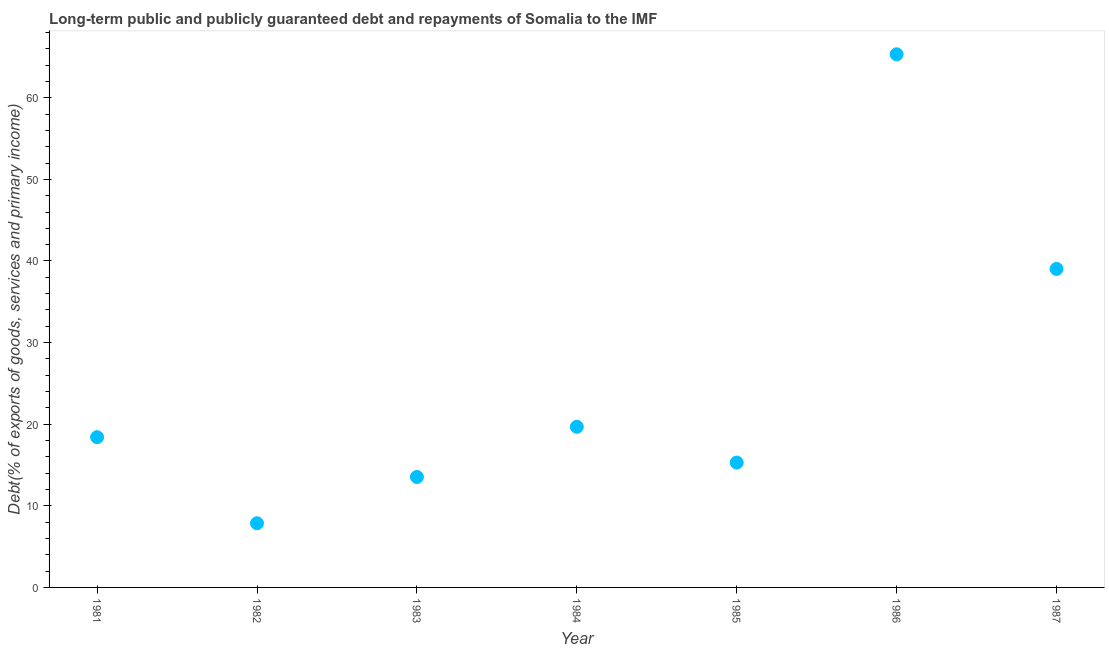What is the debt service in 1984?
Offer a terse response. 19.68. Across all years, what is the maximum debt service?
Keep it short and to the point. 65.33. Across all years, what is the minimum debt service?
Provide a succinct answer. 7.86. In which year was the debt service maximum?
Offer a terse response. 1986. What is the sum of the debt service?
Offer a very short reply. 179.14. What is the difference between the debt service in 1986 and 1987?
Offer a terse response. 26.3. What is the average debt service per year?
Offer a very short reply. 25.59. What is the median debt service?
Your answer should be very brief. 18.41. Do a majority of the years between 1987 and 1985 (inclusive) have debt service greater than 16 %?
Ensure brevity in your answer.  No. What is the ratio of the debt service in 1982 to that in 1985?
Make the answer very short. 0.51. What is the difference between the highest and the second highest debt service?
Your response must be concise. 26.3. Is the sum of the debt service in 1981 and 1984 greater than the maximum debt service across all years?
Provide a succinct answer. No. What is the difference between the highest and the lowest debt service?
Your answer should be very brief. 57.46. In how many years, is the debt service greater than the average debt service taken over all years?
Make the answer very short. 2. Does the debt service monotonically increase over the years?
Your response must be concise. No. How many dotlines are there?
Make the answer very short. 1. What is the difference between two consecutive major ticks on the Y-axis?
Offer a very short reply. 10. Are the values on the major ticks of Y-axis written in scientific E-notation?
Make the answer very short. No. Does the graph contain grids?
Your answer should be compact. No. What is the title of the graph?
Provide a short and direct response. Long-term public and publicly guaranteed debt and repayments of Somalia to the IMF. What is the label or title of the Y-axis?
Give a very brief answer. Debt(% of exports of goods, services and primary income). What is the Debt(% of exports of goods, services and primary income) in 1981?
Provide a succinct answer. 18.41. What is the Debt(% of exports of goods, services and primary income) in 1982?
Offer a very short reply. 7.86. What is the Debt(% of exports of goods, services and primary income) in 1983?
Offer a terse response. 13.53. What is the Debt(% of exports of goods, services and primary income) in 1984?
Your answer should be very brief. 19.68. What is the Debt(% of exports of goods, services and primary income) in 1985?
Your answer should be very brief. 15.3. What is the Debt(% of exports of goods, services and primary income) in 1986?
Offer a terse response. 65.33. What is the Debt(% of exports of goods, services and primary income) in 1987?
Provide a short and direct response. 39.03. What is the difference between the Debt(% of exports of goods, services and primary income) in 1981 and 1982?
Offer a terse response. 10.54. What is the difference between the Debt(% of exports of goods, services and primary income) in 1981 and 1983?
Keep it short and to the point. 4.88. What is the difference between the Debt(% of exports of goods, services and primary income) in 1981 and 1984?
Keep it short and to the point. -1.27. What is the difference between the Debt(% of exports of goods, services and primary income) in 1981 and 1985?
Provide a short and direct response. 3.11. What is the difference between the Debt(% of exports of goods, services and primary income) in 1981 and 1986?
Offer a terse response. -46.92. What is the difference between the Debt(% of exports of goods, services and primary income) in 1981 and 1987?
Your response must be concise. -20.62. What is the difference between the Debt(% of exports of goods, services and primary income) in 1982 and 1983?
Give a very brief answer. -5.67. What is the difference between the Debt(% of exports of goods, services and primary income) in 1982 and 1984?
Provide a short and direct response. -11.82. What is the difference between the Debt(% of exports of goods, services and primary income) in 1982 and 1985?
Your answer should be very brief. -7.43. What is the difference between the Debt(% of exports of goods, services and primary income) in 1982 and 1986?
Your answer should be very brief. -57.46. What is the difference between the Debt(% of exports of goods, services and primary income) in 1982 and 1987?
Provide a short and direct response. -31.16. What is the difference between the Debt(% of exports of goods, services and primary income) in 1983 and 1984?
Your answer should be compact. -6.15. What is the difference between the Debt(% of exports of goods, services and primary income) in 1983 and 1985?
Ensure brevity in your answer.  -1.76. What is the difference between the Debt(% of exports of goods, services and primary income) in 1983 and 1986?
Keep it short and to the point. -51.79. What is the difference between the Debt(% of exports of goods, services and primary income) in 1983 and 1987?
Your answer should be very brief. -25.49. What is the difference between the Debt(% of exports of goods, services and primary income) in 1984 and 1985?
Your response must be concise. 4.38. What is the difference between the Debt(% of exports of goods, services and primary income) in 1984 and 1986?
Make the answer very short. -45.65. What is the difference between the Debt(% of exports of goods, services and primary income) in 1984 and 1987?
Make the answer very short. -19.34. What is the difference between the Debt(% of exports of goods, services and primary income) in 1985 and 1986?
Keep it short and to the point. -50.03. What is the difference between the Debt(% of exports of goods, services and primary income) in 1985 and 1987?
Offer a terse response. -23.73. What is the difference between the Debt(% of exports of goods, services and primary income) in 1986 and 1987?
Your answer should be very brief. 26.3. What is the ratio of the Debt(% of exports of goods, services and primary income) in 1981 to that in 1982?
Provide a short and direct response. 2.34. What is the ratio of the Debt(% of exports of goods, services and primary income) in 1981 to that in 1983?
Keep it short and to the point. 1.36. What is the ratio of the Debt(% of exports of goods, services and primary income) in 1981 to that in 1984?
Make the answer very short. 0.94. What is the ratio of the Debt(% of exports of goods, services and primary income) in 1981 to that in 1985?
Your answer should be compact. 1.2. What is the ratio of the Debt(% of exports of goods, services and primary income) in 1981 to that in 1986?
Provide a short and direct response. 0.28. What is the ratio of the Debt(% of exports of goods, services and primary income) in 1981 to that in 1987?
Keep it short and to the point. 0.47. What is the ratio of the Debt(% of exports of goods, services and primary income) in 1982 to that in 1983?
Give a very brief answer. 0.58. What is the ratio of the Debt(% of exports of goods, services and primary income) in 1982 to that in 1985?
Ensure brevity in your answer.  0.51. What is the ratio of the Debt(% of exports of goods, services and primary income) in 1982 to that in 1986?
Make the answer very short. 0.12. What is the ratio of the Debt(% of exports of goods, services and primary income) in 1982 to that in 1987?
Keep it short and to the point. 0.2. What is the ratio of the Debt(% of exports of goods, services and primary income) in 1983 to that in 1984?
Make the answer very short. 0.69. What is the ratio of the Debt(% of exports of goods, services and primary income) in 1983 to that in 1985?
Offer a very short reply. 0.89. What is the ratio of the Debt(% of exports of goods, services and primary income) in 1983 to that in 1986?
Provide a succinct answer. 0.21. What is the ratio of the Debt(% of exports of goods, services and primary income) in 1983 to that in 1987?
Make the answer very short. 0.35. What is the ratio of the Debt(% of exports of goods, services and primary income) in 1984 to that in 1985?
Your answer should be very brief. 1.29. What is the ratio of the Debt(% of exports of goods, services and primary income) in 1984 to that in 1986?
Provide a short and direct response. 0.3. What is the ratio of the Debt(% of exports of goods, services and primary income) in 1984 to that in 1987?
Offer a terse response. 0.5. What is the ratio of the Debt(% of exports of goods, services and primary income) in 1985 to that in 1986?
Your answer should be compact. 0.23. What is the ratio of the Debt(% of exports of goods, services and primary income) in 1985 to that in 1987?
Ensure brevity in your answer.  0.39. What is the ratio of the Debt(% of exports of goods, services and primary income) in 1986 to that in 1987?
Make the answer very short. 1.67. 